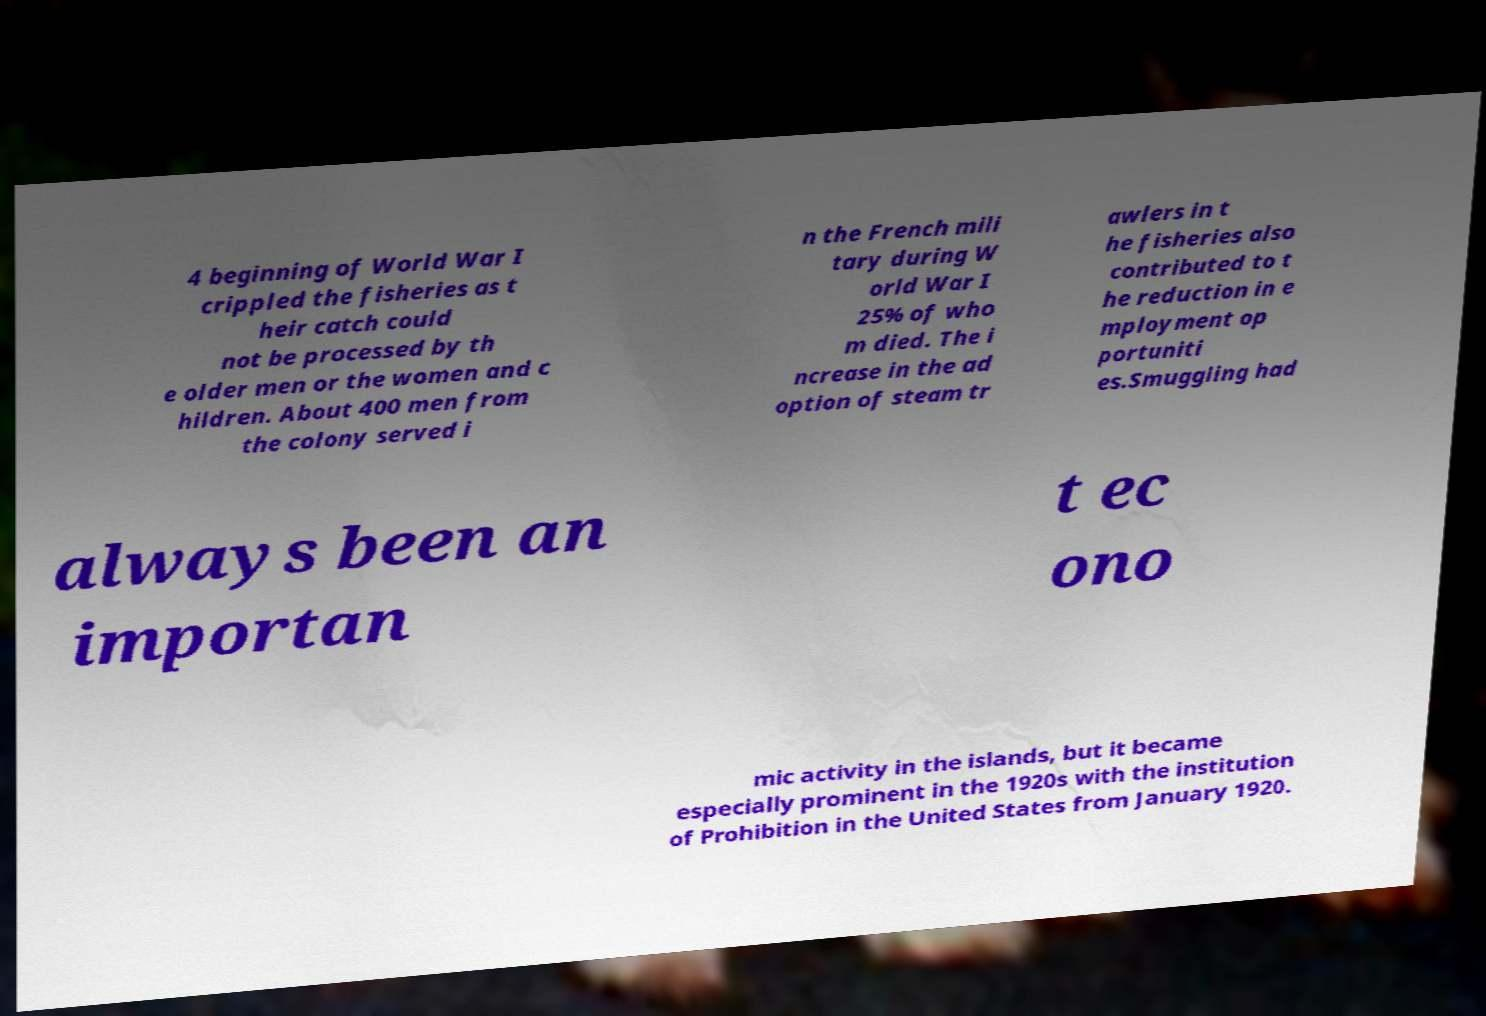There's text embedded in this image that I need extracted. Can you transcribe it verbatim? 4 beginning of World War I crippled the fisheries as t heir catch could not be processed by th e older men or the women and c hildren. About 400 men from the colony served i n the French mili tary during W orld War I 25% of who m died. The i ncrease in the ad option of steam tr awlers in t he fisheries also contributed to t he reduction in e mployment op portuniti es.Smuggling had always been an importan t ec ono mic activity in the islands, but it became especially prominent in the 1920s with the institution of Prohibition in the United States from January 1920. 